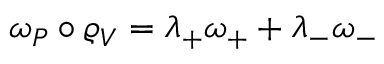Convert formula to latex. <formula><loc_0><loc_0><loc_500><loc_500>\omega _ { P } \circ \varrho _ { V } = \lambda _ { + } \omega _ { + } + \lambda _ { - } \omega _ { - }</formula> 